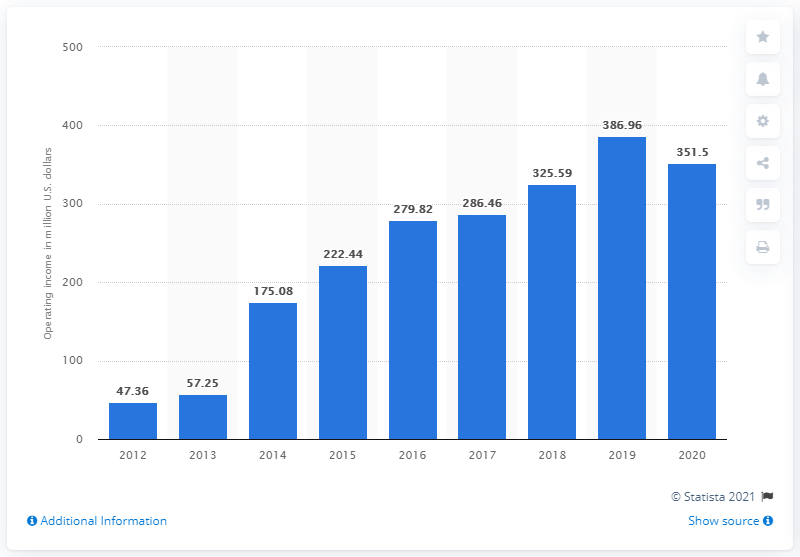Mention a couple of crucial points in this snapshot. Yamaha Corporation's operating income from musical instruments for the 2020 fiscal year was 351.5 million USD. 